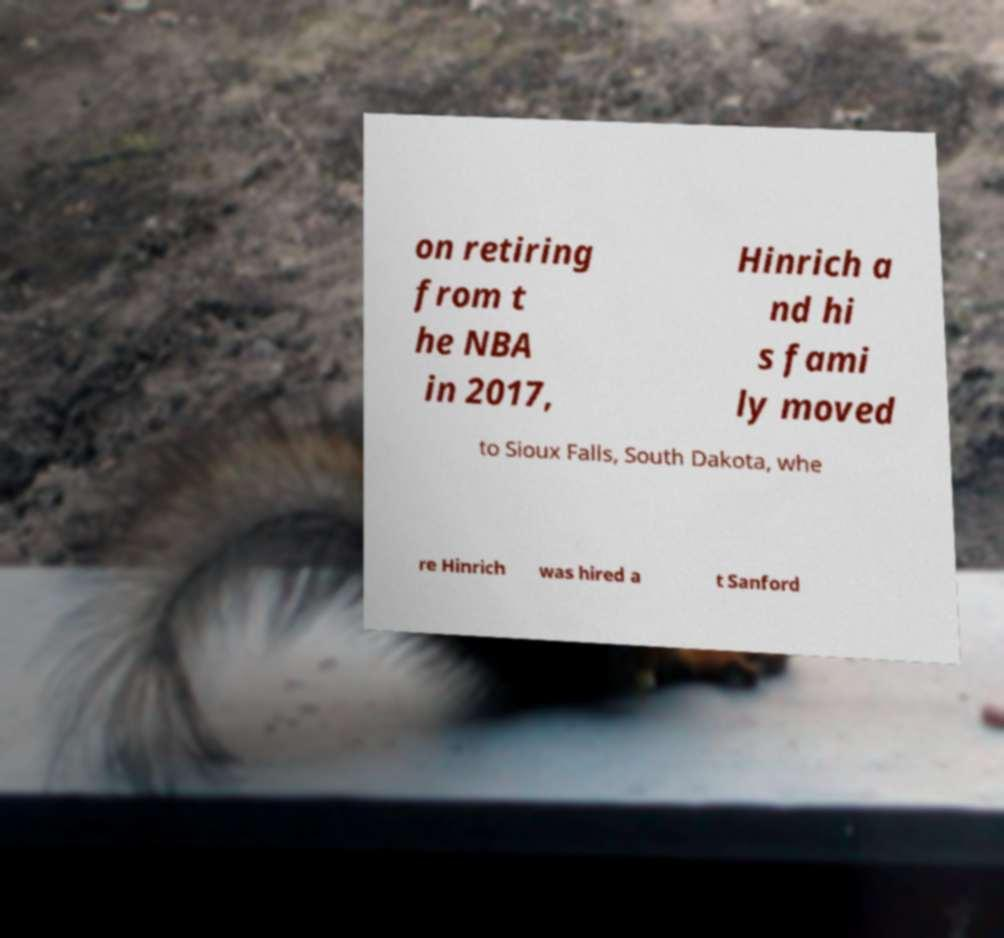Please read and relay the text visible in this image. What does it say? on retiring from t he NBA in 2017, Hinrich a nd hi s fami ly moved to Sioux Falls, South Dakota, whe re Hinrich was hired a t Sanford 